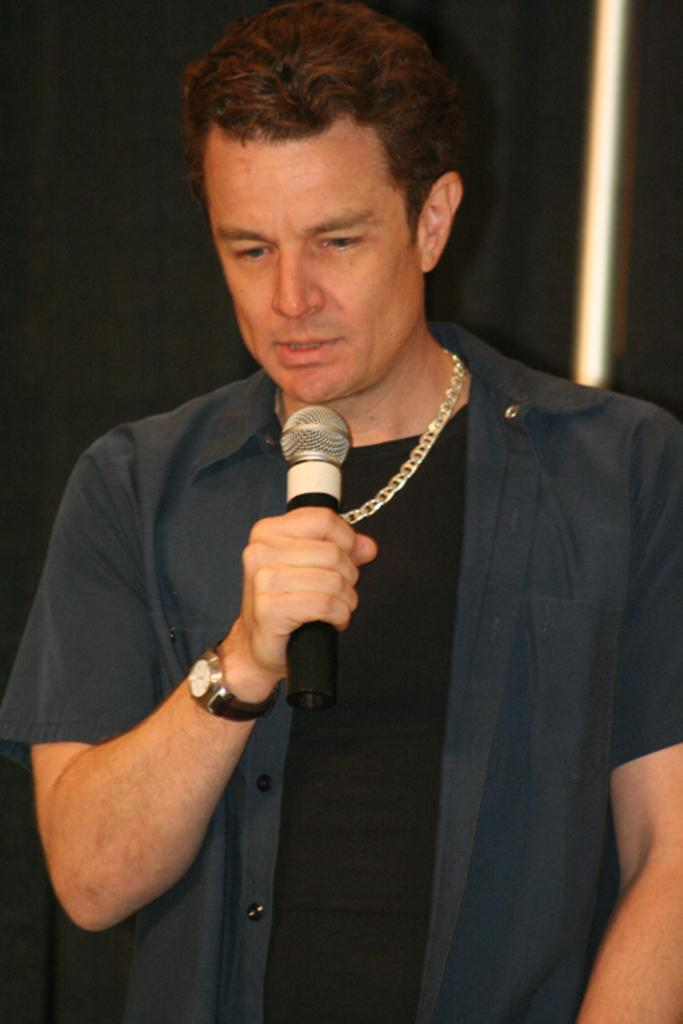What is the main subject of the image? There is a man in the image. What is the man holding in the image? The man is holding a microphone. What action is the man performing in the image? The man's mouth is open, suggesting he is talking. What accessory is the man wearing in the image? The man is wearing a watch. What is the color of the watch? The watch is black in color. What type of ornament is hanging from the man's neck in the image? There is no ornament hanging from the man's neck in the image. What type of milk is the man drinking in the image? There is no milk present in the image. Can you see any toads in the image? There are no toads present in the image. 